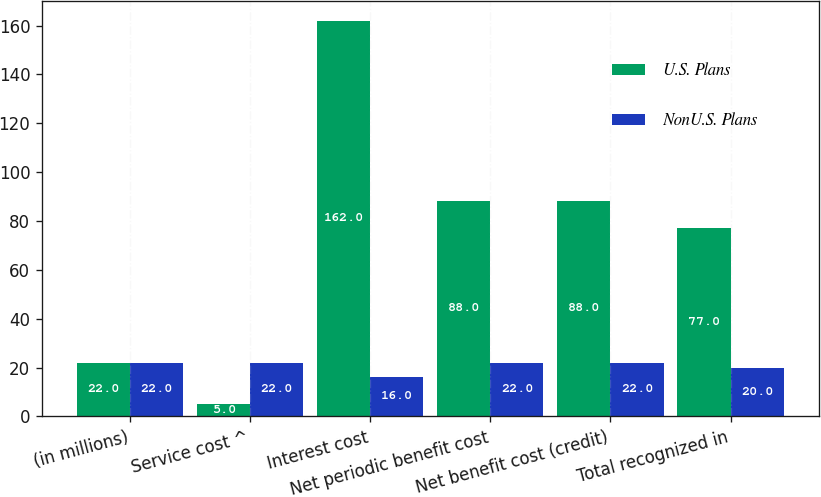Convert chart. <chart><loc_0><loc_0><loc_500><loc_500><stacked_bar_chart><ecel><fcel>(in millions)<fcel>Service cost ^<fcel>Interest cost<fcel>Net periodic benefit cost<fcel>Net benefit cost (credit)<fcel>Total recognized in<nl><fcel>U.S. Plans<fcel>22<fcel>5<fcel>162<fcel>88<fcel>88<fcel>77<nl><fcel>NonU.S. Plans<fcel>22<fcel>22<fcel>16<fcel>22<fcel>22<fcel>20<nl></chart> 